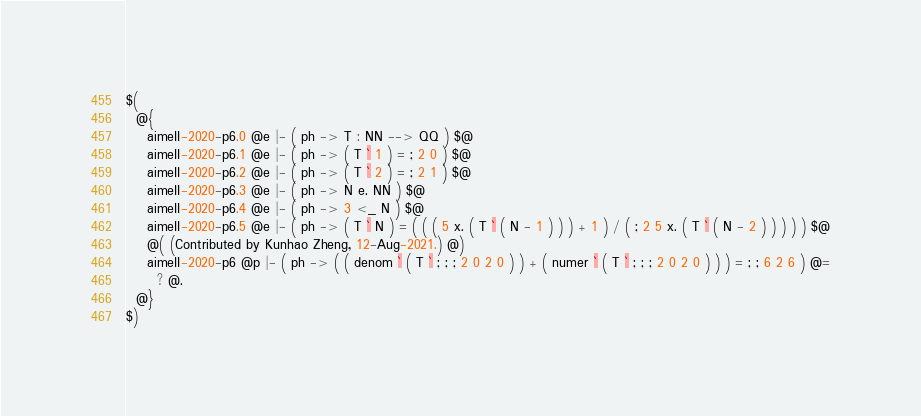Convert code to text. <code><loc_0><loc_0><loc_500><loc_500><_ObjectiveC_>$(
  @{
    aimeII-2020-p6.0 @e |- ( ph -> T : NN --> QQ ) $@
    aimeII-2020-p6.1 @e |- ( ph -> ( T ` 1 ) = ; 2 0 ) $@
    aimeII-2020-p6.2 @e |- ( ph -> ( T ` 2 ) = ; 2 1 ) $@
    aimeII-2020-p6.3 @e |- ( ph -> N e. NN ) $@
    aimeII-2020-p6.4 @e |- ( ph -> 3 <_ N ) $@
    aimeII-2020-p6.5 @e |- ( ph -> ( T ` N ) = ( ( ( 5 x. ( T ` ( N - 1 ) ) ) + 1 ) / ( ; 2 5 x. ( T ` ( N - 2 ) ) ) ) ) $@
    @( (Contributed by Kunhao Zheng, 12-Aug-2021.) @)
    aimeII-2020-p6 @p |- ( ph -> ( ( denom ` ( T ` ; ; ; 2 0 2 0 ) ) + ( numer ` ( T ` ; ; ; 2 0 2 0 ) ) ) = ; ; 6 2 6 ) @=
      ? @.
  @}
$)
</code> 